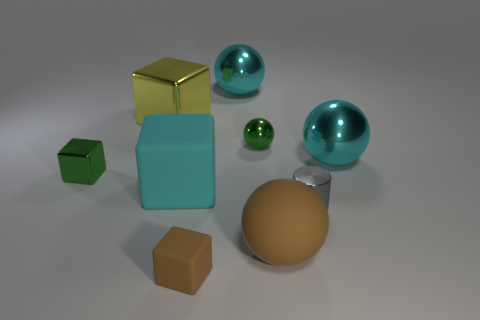There is a tiny object that is the same color as the small metallic block; what material is it?
Provide a short and direct response. Metal. Does the tiny green ball have the same material as the large cyan cube?
Your answer should be very brief. No. Are there an equal number of small gray things that are left of the yellow cube and small blue cylinders?
Your response must be concise. Yes. What number of large green spheres are the same material as the yellow object?
Your answer should be very brief. 0. Is the number of big brown objects less than the number of big cyan balls?
Offer a terse response. Yes. There is a large rubber thing that is right of the big cyan cube; does it have the same color as the small matte thing?
Offer a very short reply. Yes. There is a matte cube behind the tiny object right of the large brown rubber sphere; what number of cubes are right of it?
Keep it short and to the point. 1. There is a green cube; what number of balls are behind it?
Your response must be concise. 3. The other tiny metallic object that is the same shape as the small brown object is what color?
Your response must be concise. Green. What is the material of the large sphere that is behind the gray shiny object and in front of the yellow object?
Offer a very short reply. Metal. 